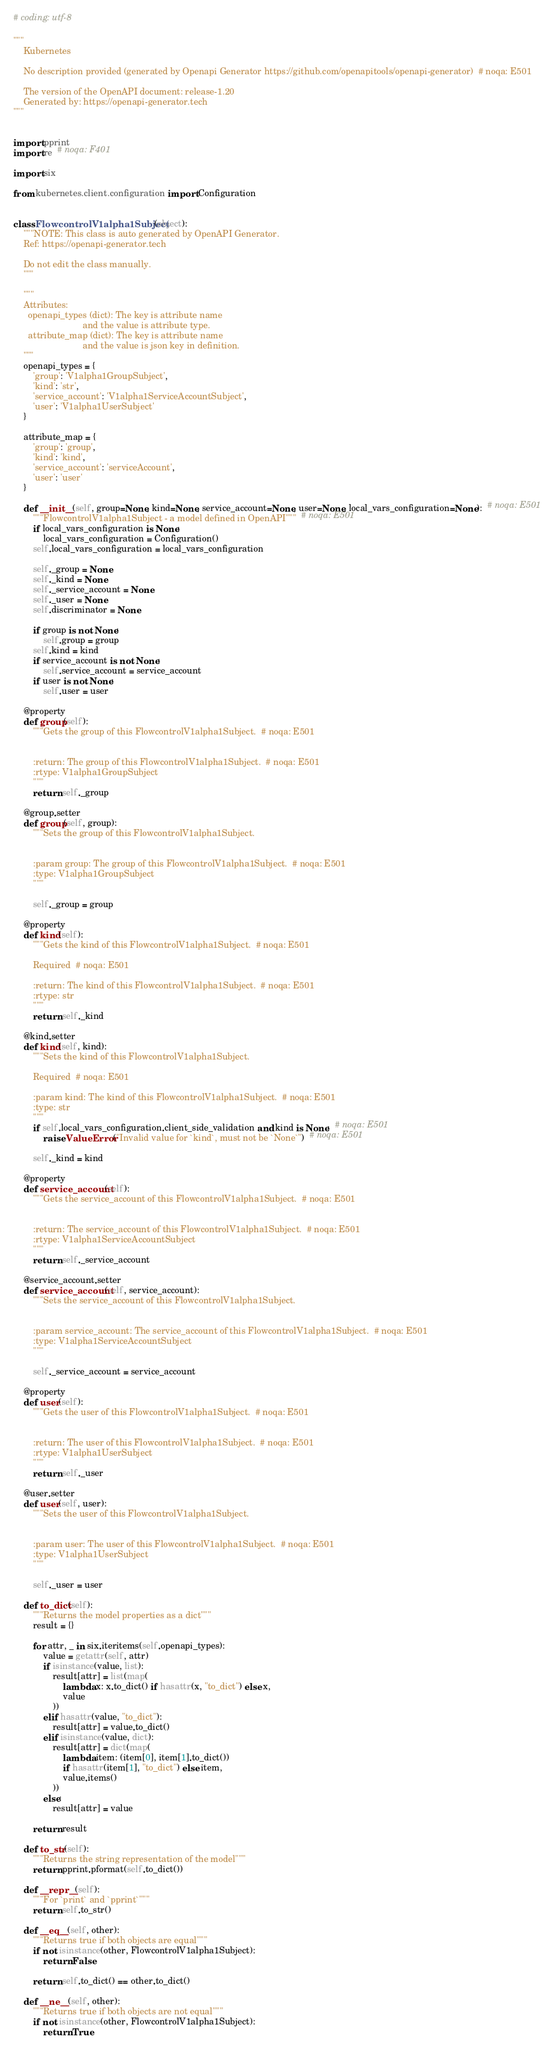Convert code to text. <code><loc_0><loc_0><loc_500><loc_500><_Python_># coding: utf-8

"""
    Kubernetes

    No description provided (generated by Openapi Generator https://github.com/openapitools/openapi-generator)  # noqa: E501

    The version of the OpenAPI document: release-1.20
    Generated by: https://openapi-generator.tech
"""


import pprint
import re  # noqa: F401

import six

from kubernetes.client.configuration import Configuration


class FlowcontrolV1alpha1Subject(object):
    """NOTE: This class is auto generated by OpenAPI Generator.
    Ref: https://openapi-generator.tech

    Do not edit the class manually.
    """

    """
    Attributes:
      openapi_types (dict): The key is attribute name
                            and the value is attribute type.
      attribute_map (dict): The key is attribute name
                            and the value is json key in definition.
    """
    openapi_types = {
        'group': 'V1alpha1GroupSubject',
        'kind': 'str',
        'service_account': 'V1alpha1ServiceAccountSubject',
        'user': 'V1alpha1UserSubject'
    }

    attribute_map = {
        'group': 'group',
        'kind': 'kind',
        'service_account': 'serviceAccount',
        'user': 'user'
    }

    def __init__(self, group=None, kind=None, service_account=None, user=None, local_vars_configuration=None):  # noqa: E501
        """FlowcontrolV1alpha1Subject - a model defined in OpenAPI"""  # noqa: E501
        if local_vars_configuration is None:
            local_vars_configuration = Configuration()
        self.local_vars_configuration = local_vars_configuration

        self._group = None
        self._kind = None
        self._service_account = None
        self._user = None
        self.discriminator = None

        if group is not None:
            self.group = group
        self.kind = kind
        if service_account is not None:
            self.service_account = service_account
        if user is not None:
            self.user = user

    @property
    def group(self):
        """Gets the group of this FlowcontrolV1alpha1Subject.  # noqa: E501


        :return: The group of this FlowcontrolV1alpha1Subject.  # noqa: E501
        :rtype: V1alpha1GroupSubject
        """
        return self._group

    @group.setter
    def group(self, group):
        """Sets the group of this FlowcontrolV1alpha1Subject.


        :param group: The group of this FlowcontrolV1alpha1Subject.  # noqa: E501
        :type: V1alpha1GroupSubject
        """

        self._group = group

    @property
    def kind(self):
        """Gets the kind of this FlowcontrolV1alpha1Subject.  # noqa: E501

        Required  # noqa: E501

        :return: The kind of this FlowcontrolV1alpha1Subject.  # noqa: E501
        :rtype: str
        """
        return self._kind

    @kind.setter
    def kind(self, kind):
        """Sets the kind of this FlowcontrolV1alpha1Subject.

        Required  # noqa: E501

        :param kind: The kind of this FlowcontrolV1alpha1Subject.  # noqa: E501
        :type: str
        """
        if self.local_vars_configuration.client_side_validation and kind is None:  # noqa: E501
            raise ValueError("Invalid value for `kind`, must not be `None`")  # noqa: E501

        self._kind = kind

    @property
    def service_account(self):
        """Gets the service_account of this FlowcontrolV1alpha1Subject.  # noqa: E501


        :return: The service_account of this FlowcontrolV1alpha1Subject.  # noqa: E501
        :rtype: V1alpha1ServiceAccountSubject
        """
        return self._service_account

    @service_account.setter
    def service_account(self, service_account):
        """Sets the service_account of this FlowcontrolV1alpha1Subject.


        :param service_account: The service_account of this FlowcontrolV1alpha1Subject.  # noqa: E501
        :type: V1alpha1ServiceAccountSubject
        """

        self._service_account = service_account

    @property
    def user(self):
        """Gets the user of this FlowcontrolV1alpha1Subject.  # noqa: E501


        :return: The user of this FlowcontrolV1alpha1Subject.  # noqa: E501
        :rtype: V1alpha1UserSubject
        """
        return self._user

    @user.setter
    def user(self, user):
        """Sets the user of this FlowcontrolV1alpha1Subject.


        :param user: The user of this FlowcontrolV1alpha1Subject.  # noqa: E501
        :type: V1alpha1UserSubject
        """

        self._user = user

    def to_dict(self):
        """Returns the model properties as a dict"""
        result = {}

        for attr, _ in six.iteritems(self.openapi_types):
            value = getattr(self, attr)
            if isinstance(value, list):
                result[attr] = list(map(
                    lambda x: x.to_dict() if hasattr(x, "to_dict") else x,
                    value
                ))
            elif hasattr(value, "to_dict"):
                result[attr] = value.to_dict()
            elif isinstance(value, dict):
                result[attr] = dict(map(
                    lambda item: (item[0], item[1].to_dict())
                    if hasattr(item[1], "to_dict") else item,
                    value.items()
                ))
            else:
                result[attr] = value

        return result

    def to_str(self):
        """Returns the string representation of the model"""
        return pprint.pformat(self.to_dict())

    def __repr__(self):
        """For `print` and `pprint`"""
        return self.to_str()

    def __eq__(self, other):
        """Returns true if both objects are equal"""
        if not isinstance(other, FlowcontrolV1alpha1Subject):
            return False

        return self.to_dict() == other.to_dict()

    def __ne__(self, other):
        """Returns true if both objects are not equal"""
        if not isinstance(other, FlowcontrolV1alpha1Subject):
            return True
</code> 